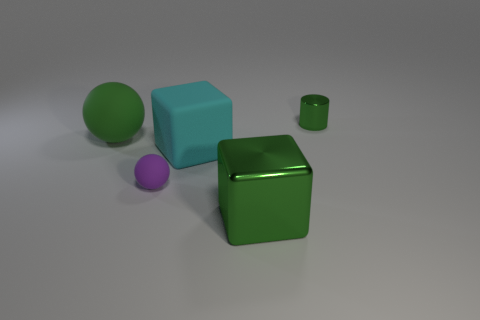Is the number of matte objects that are to the left of the small green metallic thing the same as the number of big brown rubber cylinders?
Your answer should be compact. No. Is the tiny green object made of the same material as the small sphere?
Keep it short and to the point. No. How big is the object that is both to the right of the large cyan cube and in front of the tiny metallic object?
Make the answer very short. Large. What number of other green spheres are the same size as the green sphere?
Make the answer very short. 0. There is a green metallic thing right of the big object that is in front of the small sphere; how big is it?
Your answer should be compact. Small. There is a metal thing in front of the small green thing; is its shape the same as the small thing that is to the left of the green cylinder?
Your response must be concise. No. There is a rubber thing that is behind the purple matte object and to the left of the matte cube; what color is it?
Offer a very short reply. Green. Are there any spheres of the same color as the large metallic object?
Your answer should be compact. Yes. The big rubber thing right of the green rubber thing is what color?
Your response must be concise. Cyan. There is a metallic thing in front of the cylinder; is there a green block behind it?
Keep it short and to the point. No. 